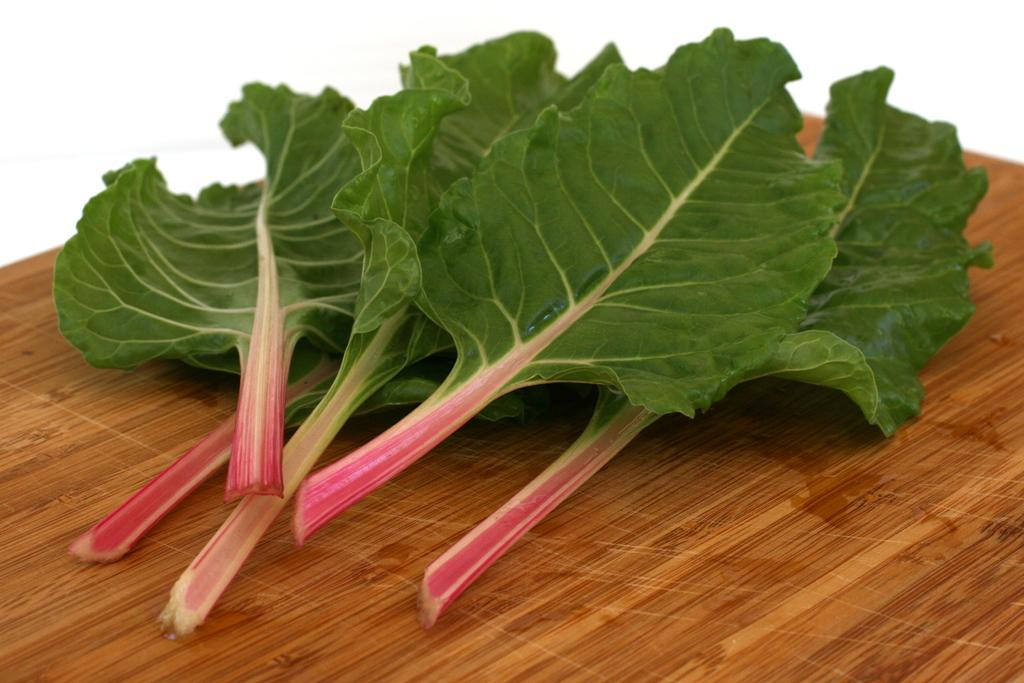What type of vegetation is present in the image? There are green leaves in the image. Where are the green leaves located? The green leaves are placed on a wooden table. What type of produce is the rabbit eating in the image? There is no rabbit present in the image, and therefore no produce or eating activity can be observed. 